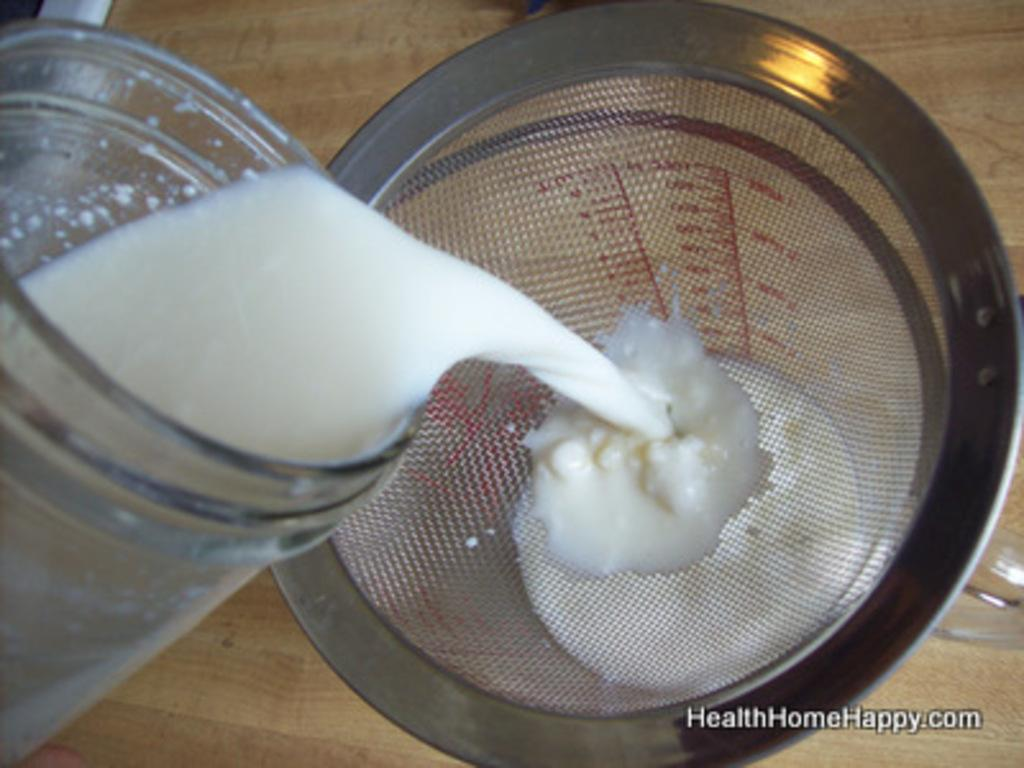What is the main object in the image? There is an infuser in the image. What type of container is present in the image? There is a glass jar in the image. What color is the liquid inside the jar? The liquid in the jar is white. What color is the background of the image? The background of the image is cream-colored. How many locks can be seen securing the building in the image? There is no building or locks present in the image; it features an infuser and a glass jar with white liquid. What type of snakes are visible in the image? There are no snakes present in the image. 